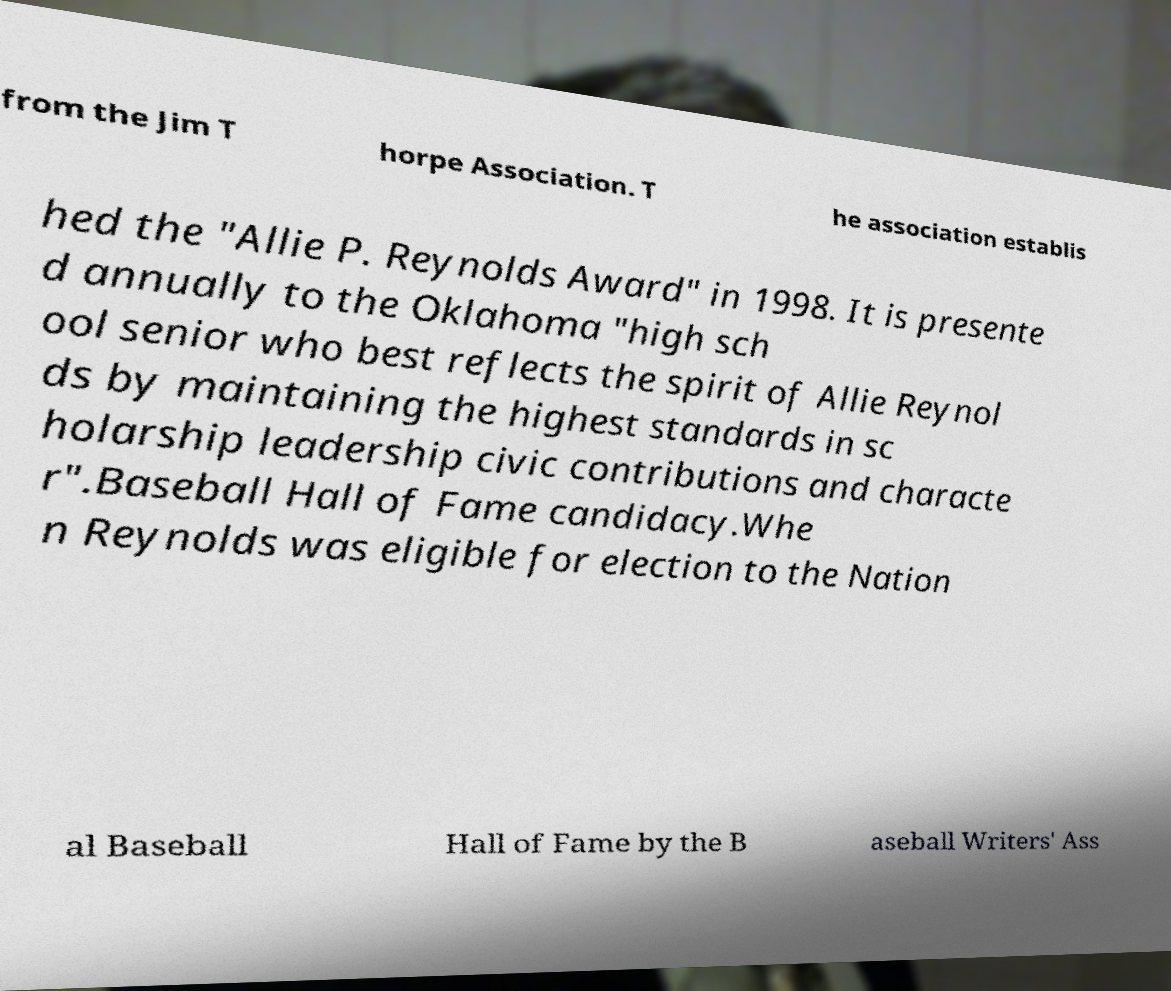Please read and relay the text visible in this image. What does it say? from the Jim T horpe Association. T he association establis hed the "Allie P. Reynolds Award" in 1998. It is presente d annually to the Oklahoma "high sch ool senior who best reflects the spirit of Allie Reynol ds by maintaining the highest standards in sc holarship leadership civic contributions and characte r".Baseball Hall of Fame candidacy.Whe n Reynolds was eligible for election to the Nation al Baseball Hall of Fame by the B aseball Writers' Ass 